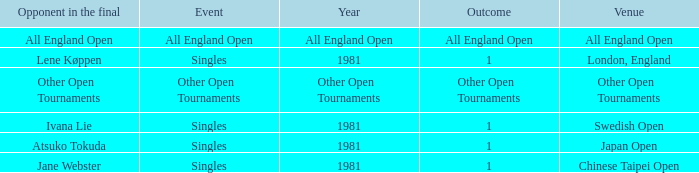Can you give me this table as a dict? {'header': ['Opponent in the final', 'Event', 'Year', 'Outcome', 'Venue'], 'rows': [['All England Open', 'All England Open', 'All England Open', 'All England Open', 'All England Open'], ['Lene Køppen', 'Singles', '1981', '1', 'London, England'], ['Other Open Tournaments', 'Other Open Tournaments', 'Other Open Tournaments', 'Other Open Tournaments', 'Other Open Tournaments'], ['Ivana Lie', 'Singles', '1981', '1', 'Swedish Open'], ['Atsuko Tokuda', 'Singles', '1981', '1', 'Japan Open'], ['Jane Webster', 'Singles', '1981', '1', 'Chinese Taipei Open']]} Who was the Opponent in London, England with an Outcome of 1? Lene Køppen. 